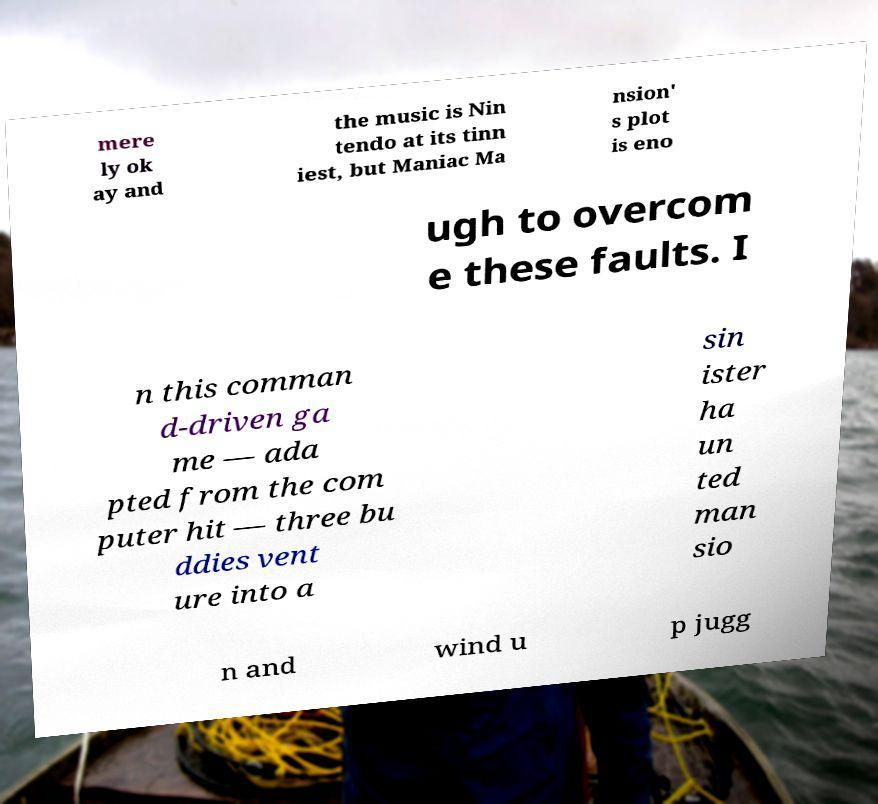Please identify and transcribe the text found in this image. mere ly ok ay and the music is Nin tendo at its tinn iest, but Maniac Ma nsion' s plot is eno ugh to overcom e these faults. I n this comman d-driven ga me — ada pted from the com puter hit — three bu ddies vent ure into a sin ister ha un ted man sio n and wind u p jugg 